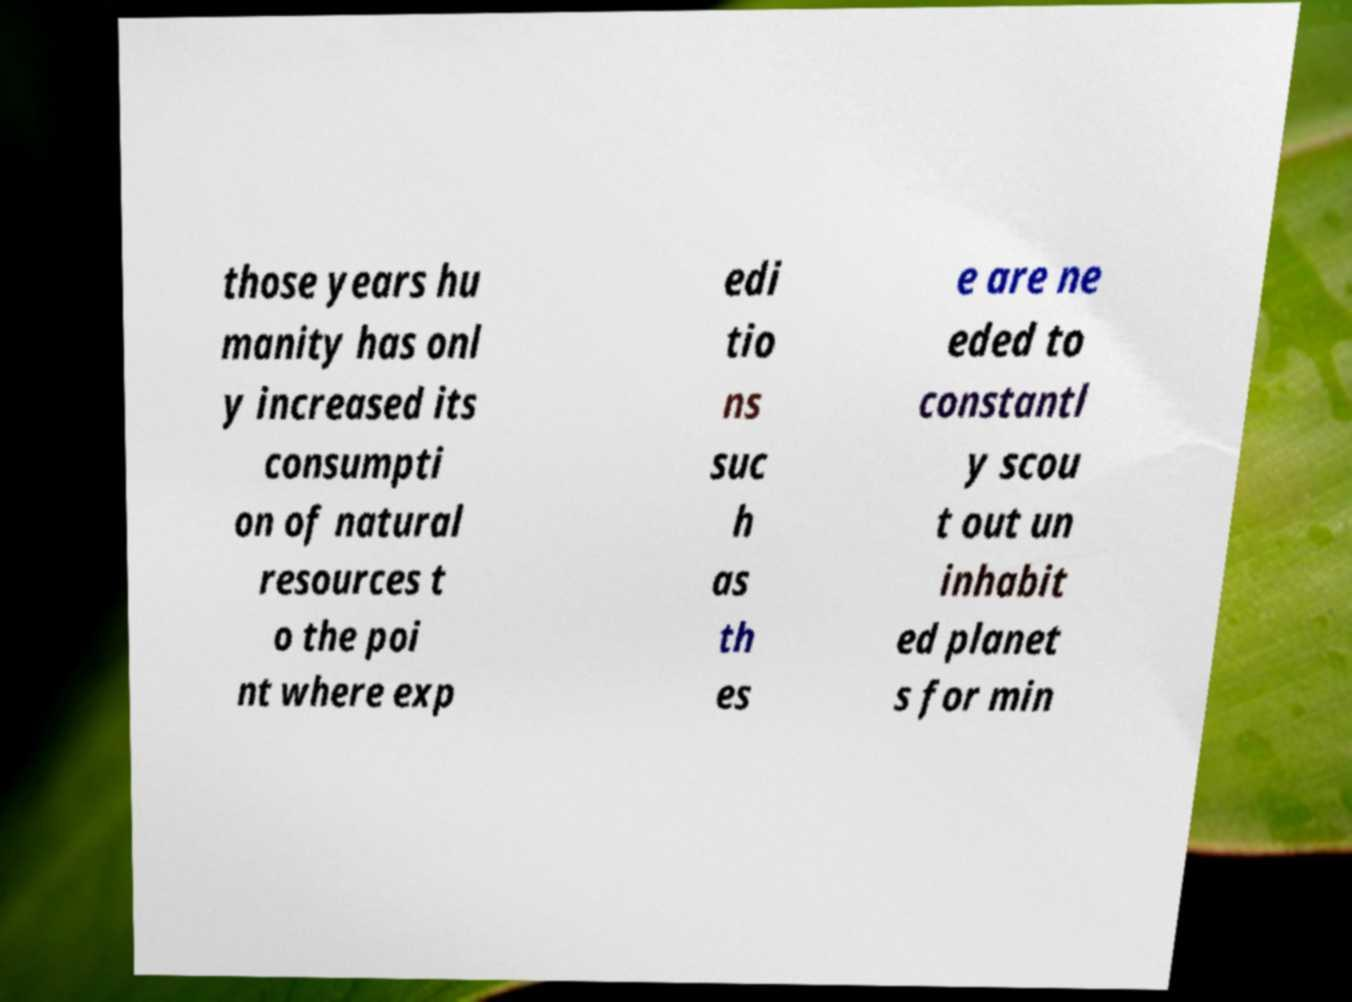Please read and relay the text visible in this image. What does it say? those years hu manity has onl y increased its consumpti on of natural resources t o the poi nt where exp edi tio ns suc h as th es e are ne eded to constantl y scou t out un inhabit ed planet s for min 